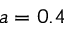<formula> <loc_0><loc_0><loc_500><loc_500>a = 0 . 4</formula> 